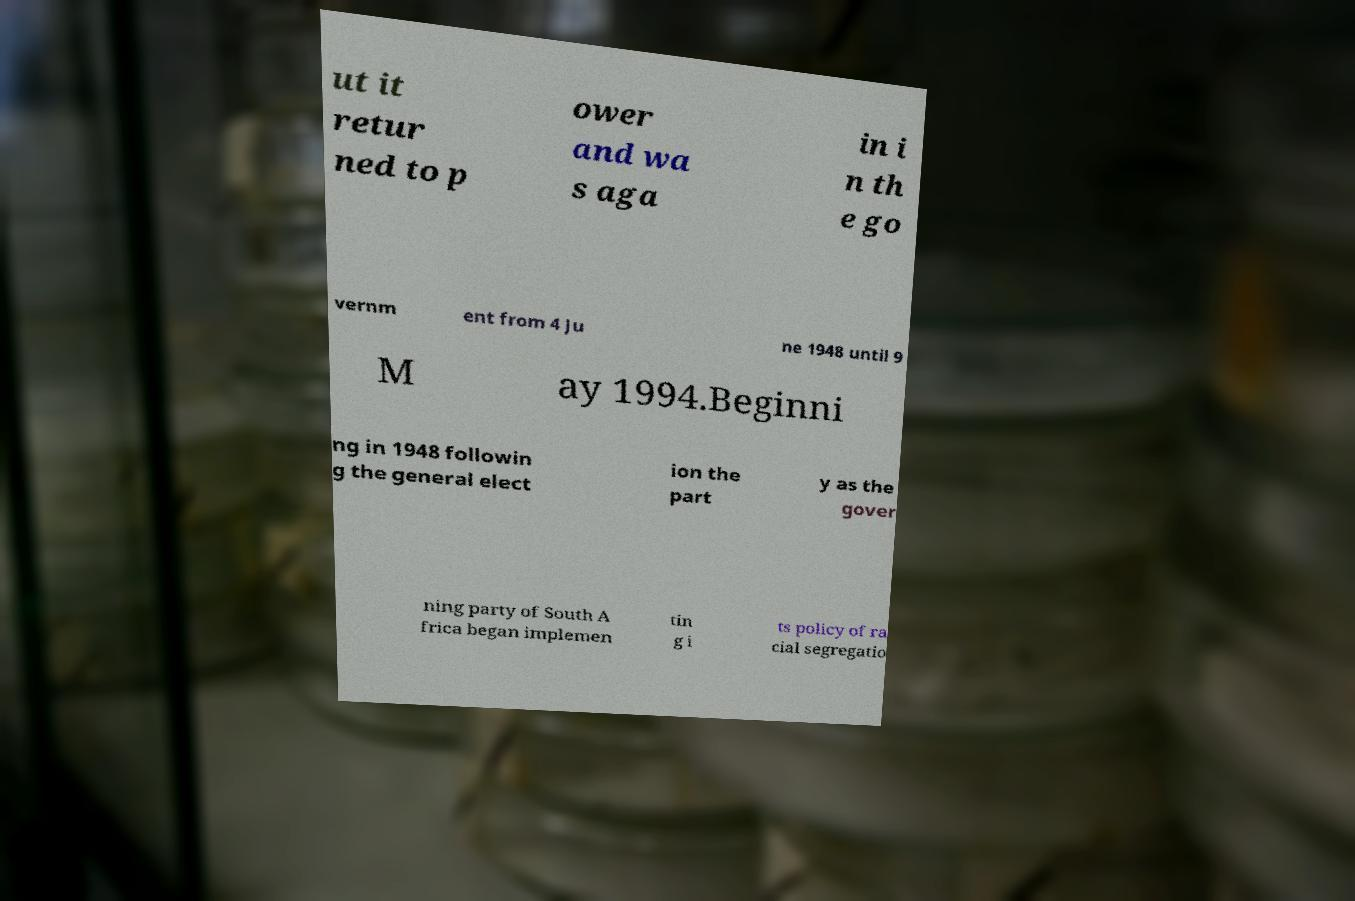For documentation purposes, I need the text within this image transcribed. Could you provide that? ut it retur ned to p ower and wa s aga in i n th e go vernm ent from 4 Ju ne 1948 until 9 M ay 1994.Beginni ng in 1948 followin g the general elect ion the part y as the gover ning party of South A frica began implemen tin g i ts policy of ra cial segregatio 